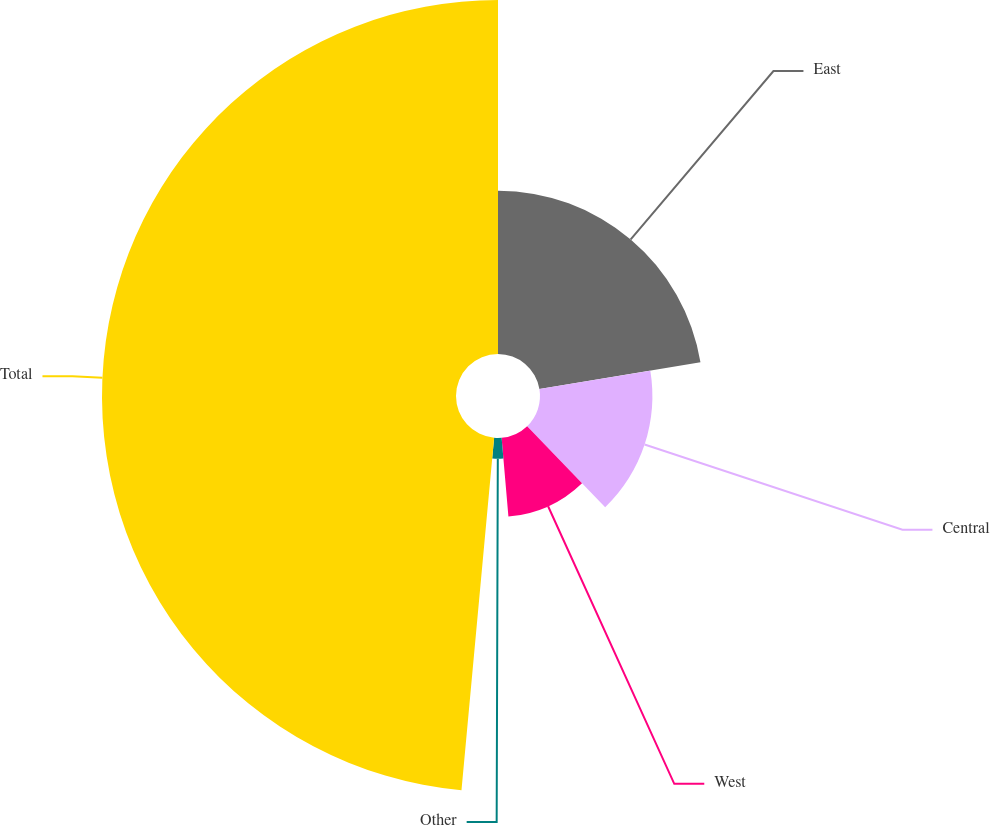<chart> <loc_0><loc_0><loc_500><loc_500><pie_chart><fcel>East<fcel>Central<fcel>West<fcel>Other<fcel>Total<nl><fcel>22.38%<fcel>15.41%<fcel>10.84%<fcel>2.84%<fcel>48.53%<nl></chart> 